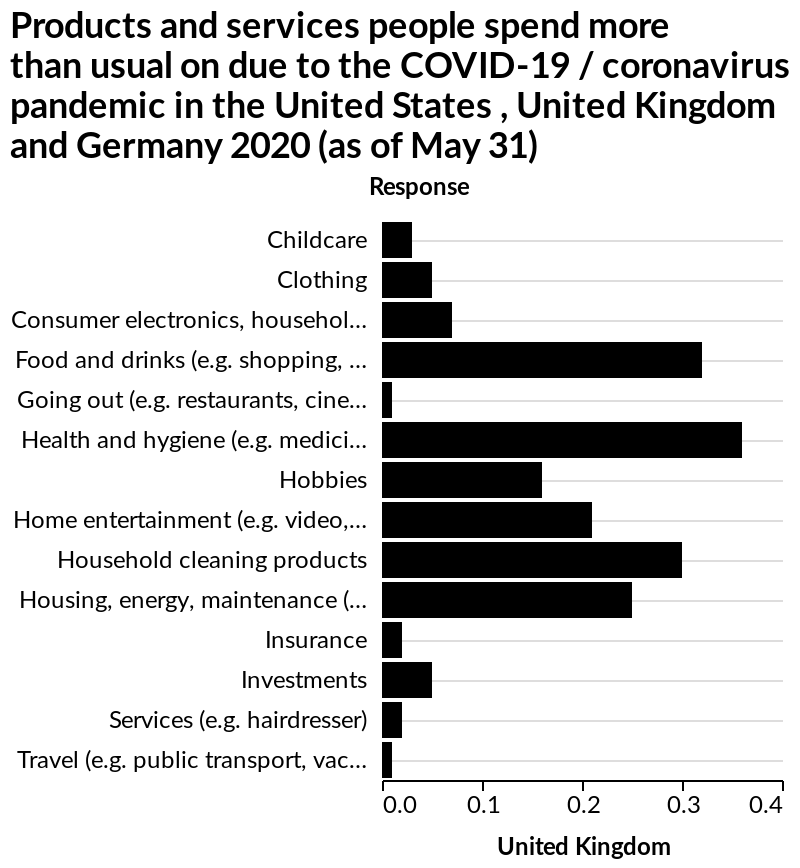<image>
What is the timeframe of the data presented in the bar diagram? The data in the bar diagram is based on information as of May 31, 2020. What does the x-axis represent in the bar diagram?  The x-axis represents the United Kingdom along a linear scale ranging from 0.0 to 0.4. 